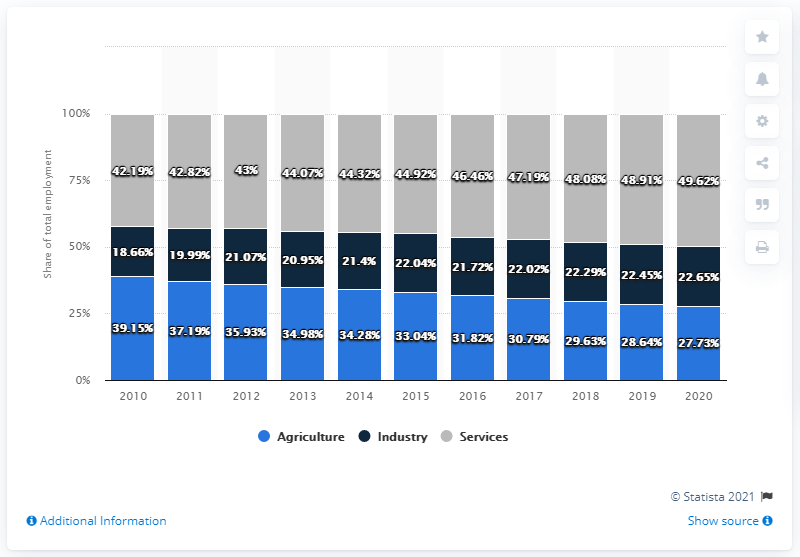List a handful of essential elements in this visual. The sum of agriculture and industry was the lowest in the employment distribution of Indonesia in the year 2020. The industry sector has been consistently shrinking year by year, indicating a decline in its overall size and significance. 